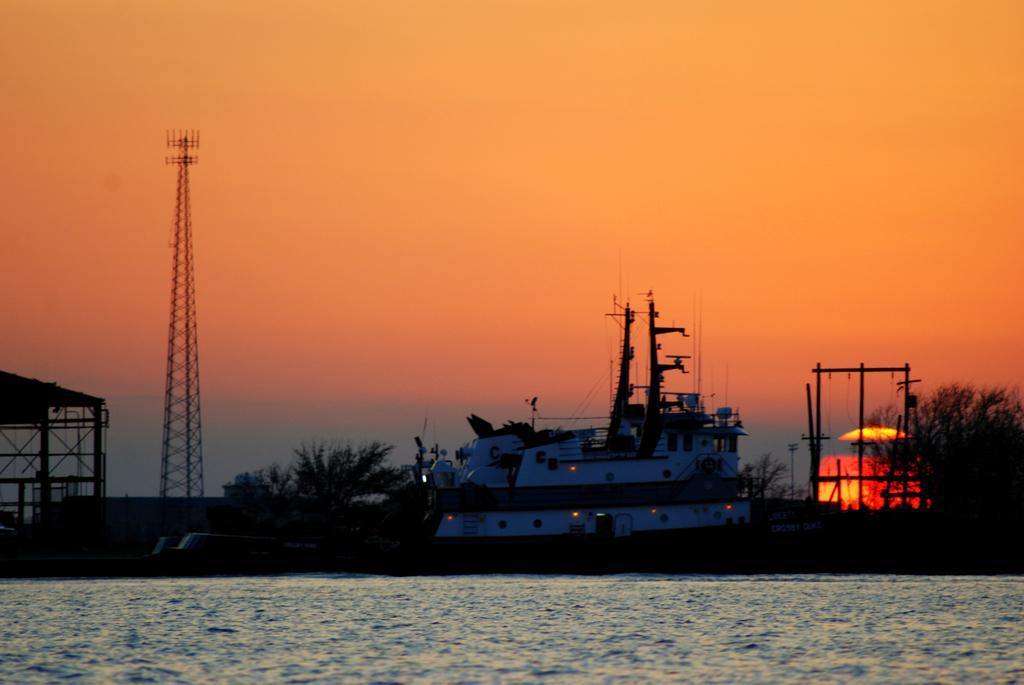Can you describe this image briefly? In this image in the center there is water and in the background is a ship, there are trees, there is a tower. On the left side there is a shed. 